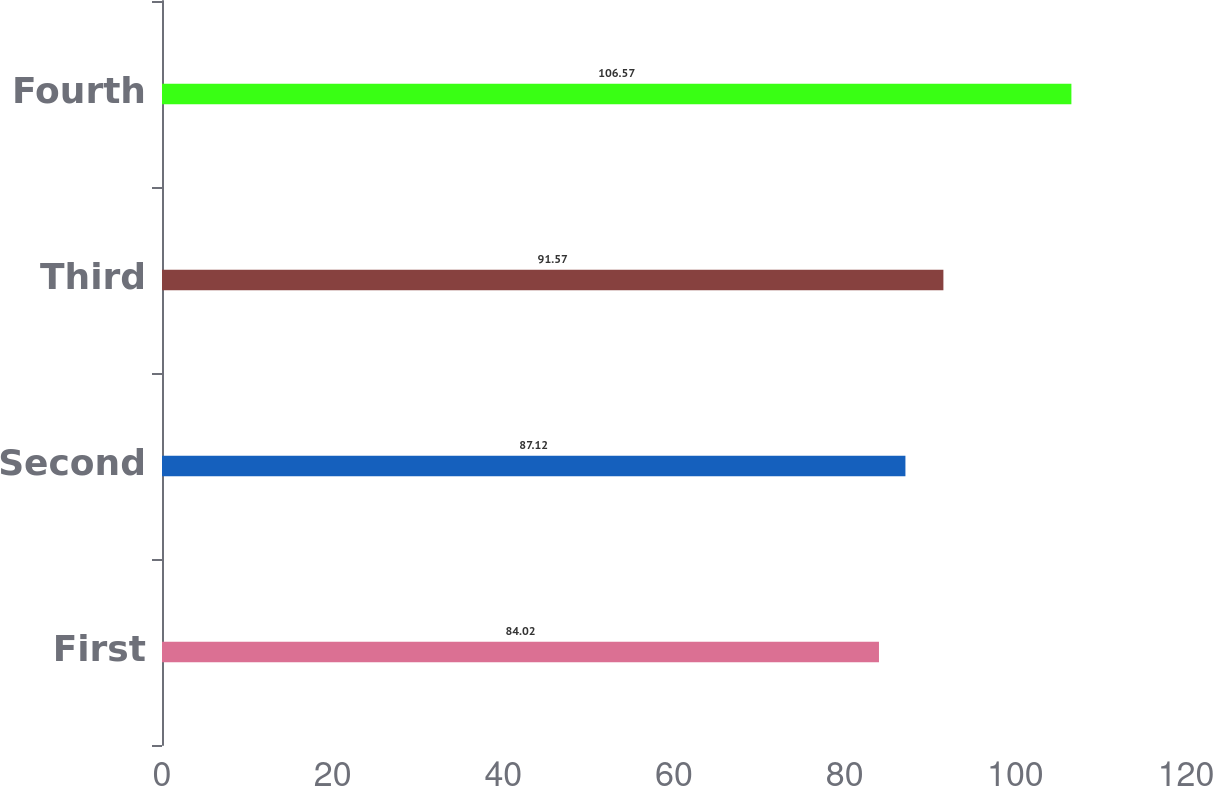Convert chart to OTSL. <chart><loc_0><loc_0><loc_500><loc_500><bar_chart><fcel>First<fcel>Second<fcel>Third<fcel>Fourth<nl><fcel>84.02<fcel>87.12<fcel>91.57<fcel>106.57<nl></chart> 